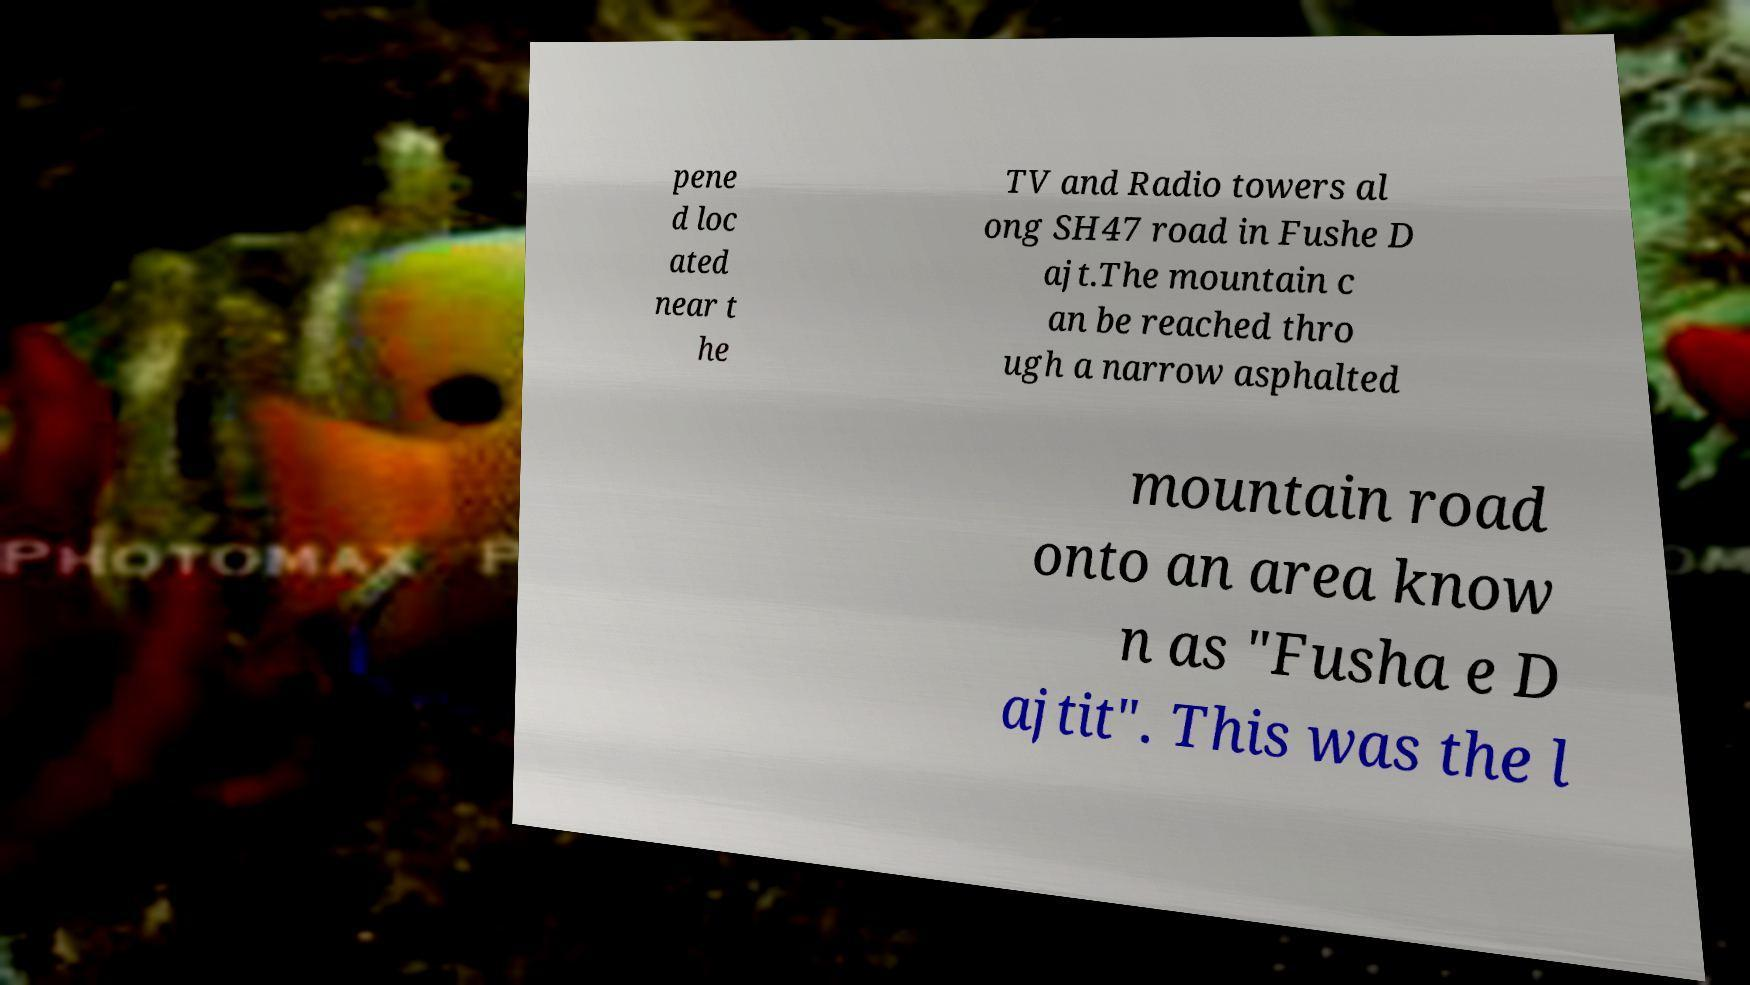What messages or text are displayed in this image? I need them in a readable, typed format. pene d loc ated near t he TV and Radio towers al ong SH47 road in Fushe D ajt.The mountain c an be reached thro ugh a narrow asphalted mountain road onto an area know n as "Fusha e D ajtit". This was the l 